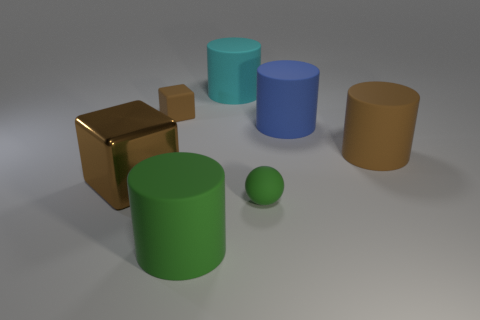There is a brown matte object to the right of the cyan object; is it the same size as the small green rubber ball?
Your response must be concise. No. There is a small rubber object that is the same color as the large metallic object; what is its shape?
Offer a terse response. Cube. How many big cyan things are made of the same material as the small brown cube?
Offer a terse response. 1. What material is the green thing behind the cylinder that is on the left side of the cyan matte cylinder that is behind the big metallic object?
Give a very brief answer. Rubber. There is a rubber cylinder that is in front of the brown rubber thing in front of the tiny block; what color is it?
Your answer should be very brief. Green. There is a metal cube that is the same size as the cyan cylinder; what color is it?
Ensure brevity in your answer.  Brown. What number of large things are matte things or green matte objects?
Provide a succinct answer. 4. Are there more tiny objects to the left of the tiny green ball than big cyan matte cylinders in front of the small cube?
Give a very brief answer. Yes. There is a cylinder that is the same color as the metal cube; what is its size?
Make the answer very short. Large. How many other things are there of the same size as the blue matte thing?
Ensure brevity in your answer.  4. 